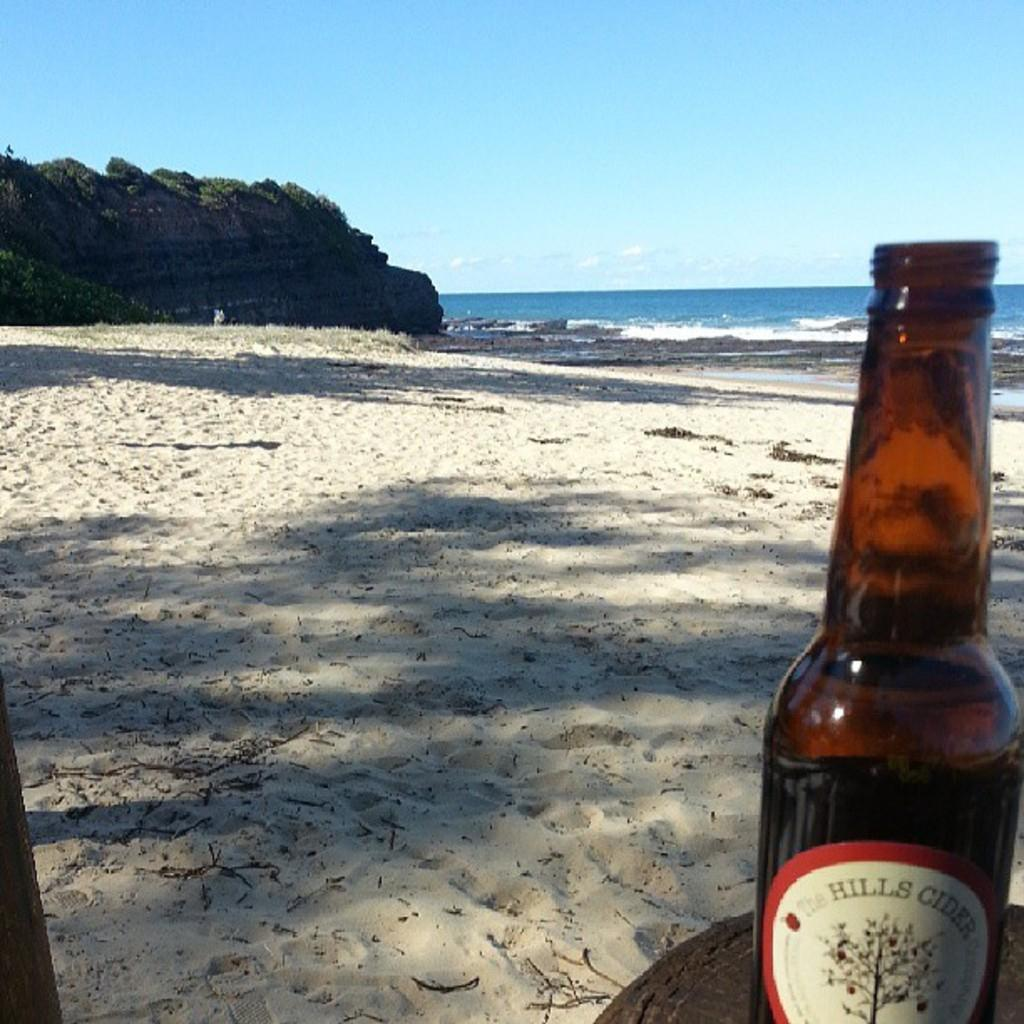<image>
Summarize the visual content of the image. A bottle of Hills Cider is in the foreground on a beach. 